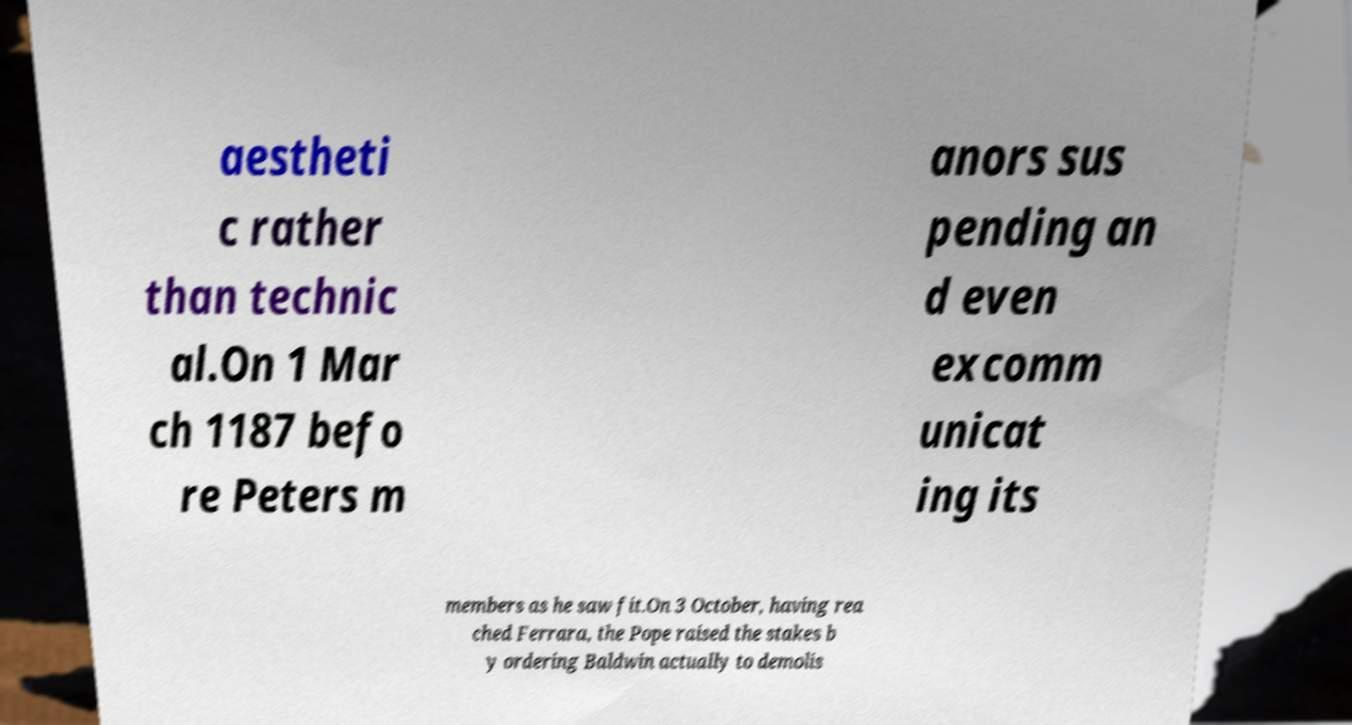Could you extract and type out the text from this image? aestheti c rather than technic al.On 1 Mar ch 1187 befo re Peters m anors sus pending an d even excomm unicat ing its members as he saw fit.On 3 October, having rea ched Ferrara, the Pope raised the stakes b y ordering Baldwin actually to demolis 